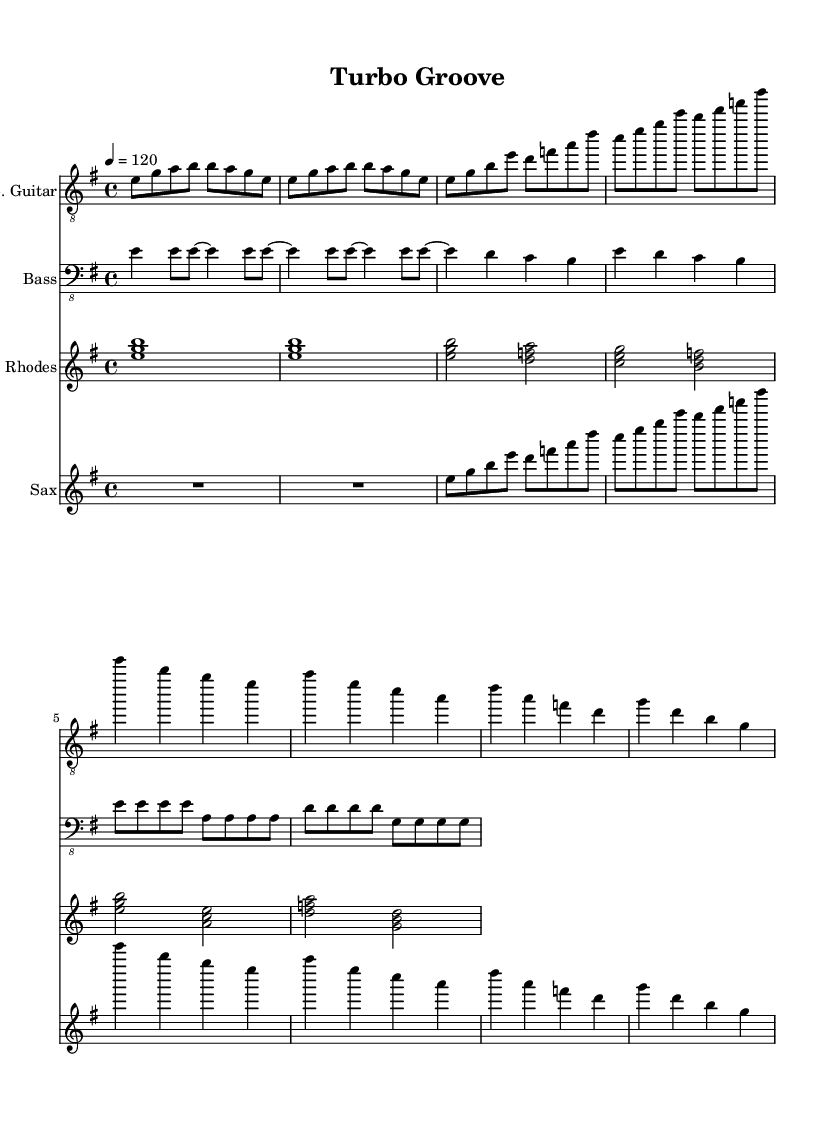What is the key signature of this music? The key signature is E minor, which has one sharp (F#). This is identifiable in the sheet music by looking for the sharp symbol located on the F line of the staff.
Answer: E minor What is the tempo marking for this piece? The tempo marking indicates a speed of 120 beats per minute. This is found in the tempo indication at the beginning of the score, which specifies "4 = 120".
Answer: 120 What is the time signature of this music? The time signature is 4/4, indicating four beats per measure. This can be seen at the beginning of the score, where the time signature is displayed as "4/4".
Answer: 4/4 How many measures does the electric guitar part have? The electric guitar part consists of eight measures. This can be counted by reviewing the bar lines, which separate the measures in the sheet music.
Answer: 8 Which instrument plays a chord at the beginning? The Rhodes plays a chord at the beginning, as shown in the first measure marked by the chord symbols that indicate multiple notes played together.
Answer: Rhodes What two instruments have the same rhythmic structure? The bass guitar and electric guitar share the same rhythmic structure throughout their parts. This can be determined by analyzing the note durations and placements in both parts, which align closely in rhythm.
Answer: Bass and Electric Guitar What is the last note played in the saxophone part? The last note in the saxophone part is G. This can be observed by examining the final measure of the saxophonist’s staff, where the note is clearly notated.
Answer: G 